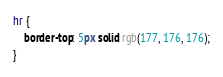<code> <loc_0><loc_0><loc_500><loc_500><_CSS_>hr {
    border-top: 5px solid rgb(177, 176, 176);
}</code> 